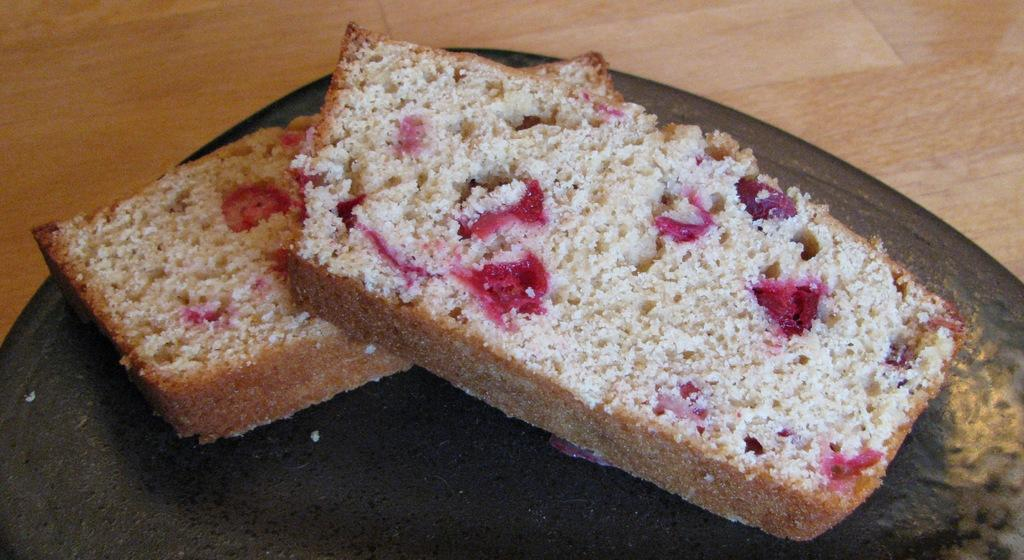What is present on the pan in the image? There are two bread pieces on the pan in the image. Where is the pan located? The pan is on a platform in the image. What type of bead is used to decorate the cake in the image? There is no cake present in the image, and therefore no beads for decoration. 